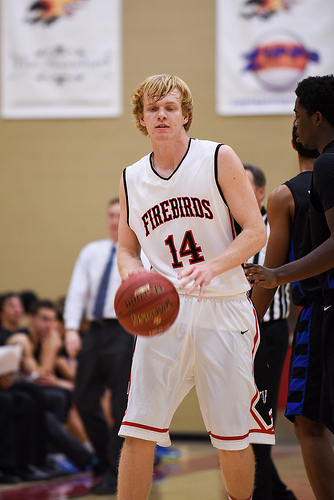<image>
Can you confirm if the man is on the ball? Yes. Looking at the image, I can see the man is positioned on top of the ball, with the ball providing support. Is there a ball on the floor? No. The ball is not positioned on the floor. They may be near each other, but the ball is not supported by or resting on top of the floor. Is the coach to the right of the basketball player? No. The coach is not to the right of the basketball player. The horizontal positioning shows a different relationship. 